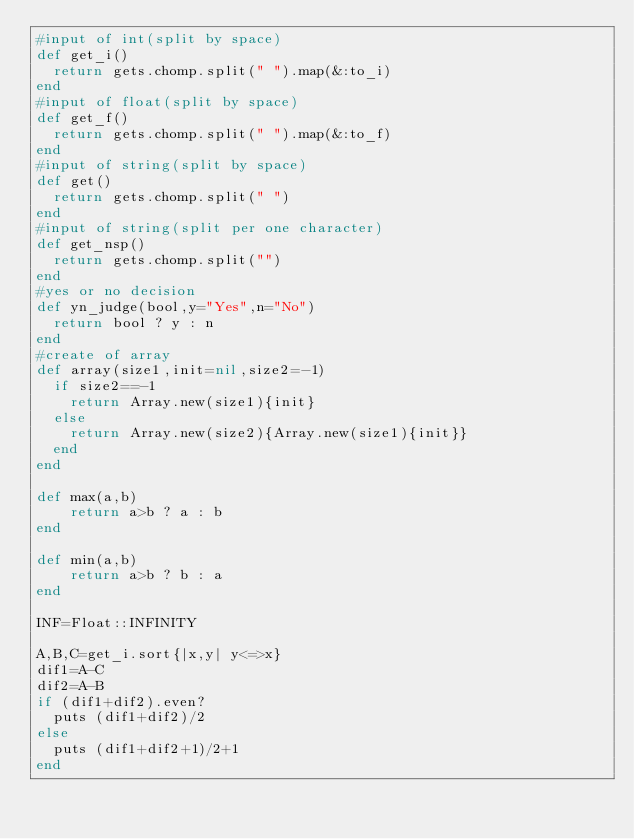<code> <loc_0><loc_0><loc_500><loc_500><_Ruby_>#input of int(split by space)
def get_i()
  return gets.chomp.split(" ").map(&:to_i)
end
#input of float(split by space)
def get_f()
  return gets.chomp.split(" ").map(&:to_f)
end
#input of string(split by space)
def get()
  return gets.chomp.split(" ")
end
#input of string(split per one character)
def get_nsp()
  return gets.chomp.split("")
end
#yes or no decision
def yn_judge(bool,y="Yes",n="No")
  return bool ? y : n 
end
#create of array
def array(size1,init=nil,size2=-1)
  if size2==-1
    return Array.new(size1){init}
  else
    return Array.new(size2){Array.new(size1){init}}
  end
end

def max(a,b)
    return a>b ? a : b
end

def min(a,b)
    return a>b ? b : a
end

INF=Float::INFINITY

A,B,C=get_i.sort{|x,y| y<=>x}
dif1=A-C
dif2=A-B
if (dif1+dif2).even?
  puts (dif1+dif2)/2
else
  puts (dif1+dif2+1)/2+1
end</code> 